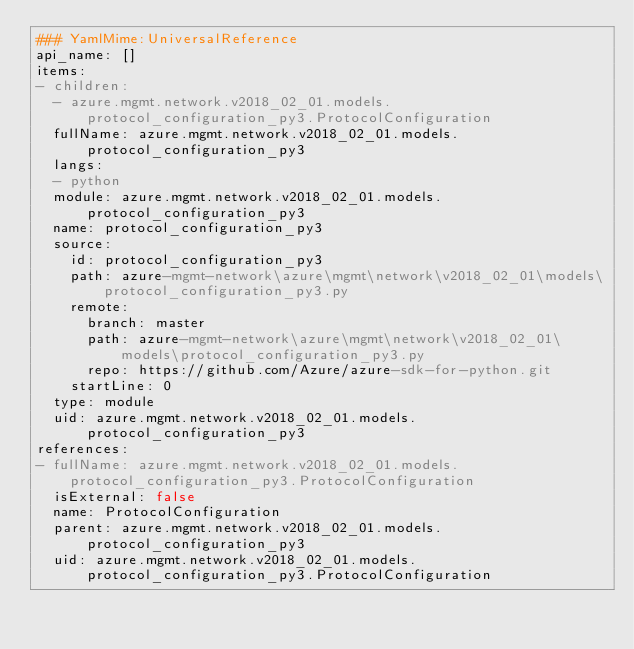<code> <loc_0><loc_0><loc_500><loc_500><_YAML_>### YamlMime:UniversalReference
api_name: []
items:
- children:
  - azure.mgmt.network.v2018_02_01.models.protocol_configuration_py3.ProtocolConfiguration
  fullName: azure.mgmt.network.v2018_02_01.models.protocol_configuration_py3
  langs:
  - python
  module: azure.mgmt.network.v2018_02_01.models.protocol_configuration_py3
  name: protocol_configuration_py3
  source:
    id: protocol_configuration_py3
    path: azure-mgmt-network\azure\mgmt\network\v2018_02_01\models\protocol_configuration_py3.py
    remote:
      branch: master
      path: azure-mgmt-network\azure\mgmt\network\v2018_02_01\models\protocol_configuration_py3.py
      repo: https://github.com/Azure/azure-sdk-for-python.git
    startLine: 0
  type: module
  uid: azure.mgmt.network.v2018_02_01.models.protocol_configuration_py3
references:
- fullName: azure.mgmt.network.v2018_02_01.models.protocol_configuration_py3.ProtocolConfiguration
  isExternal: false
  name: ProtocolConfiguration
  parent: azure.mgmt.network.v2018_02_01.models.protocol_configuration_py3
  uid: azure.mgmt.network.v2018_02_01.models.protocol_configuration_py3.ProtocolConfiguration
</code> 